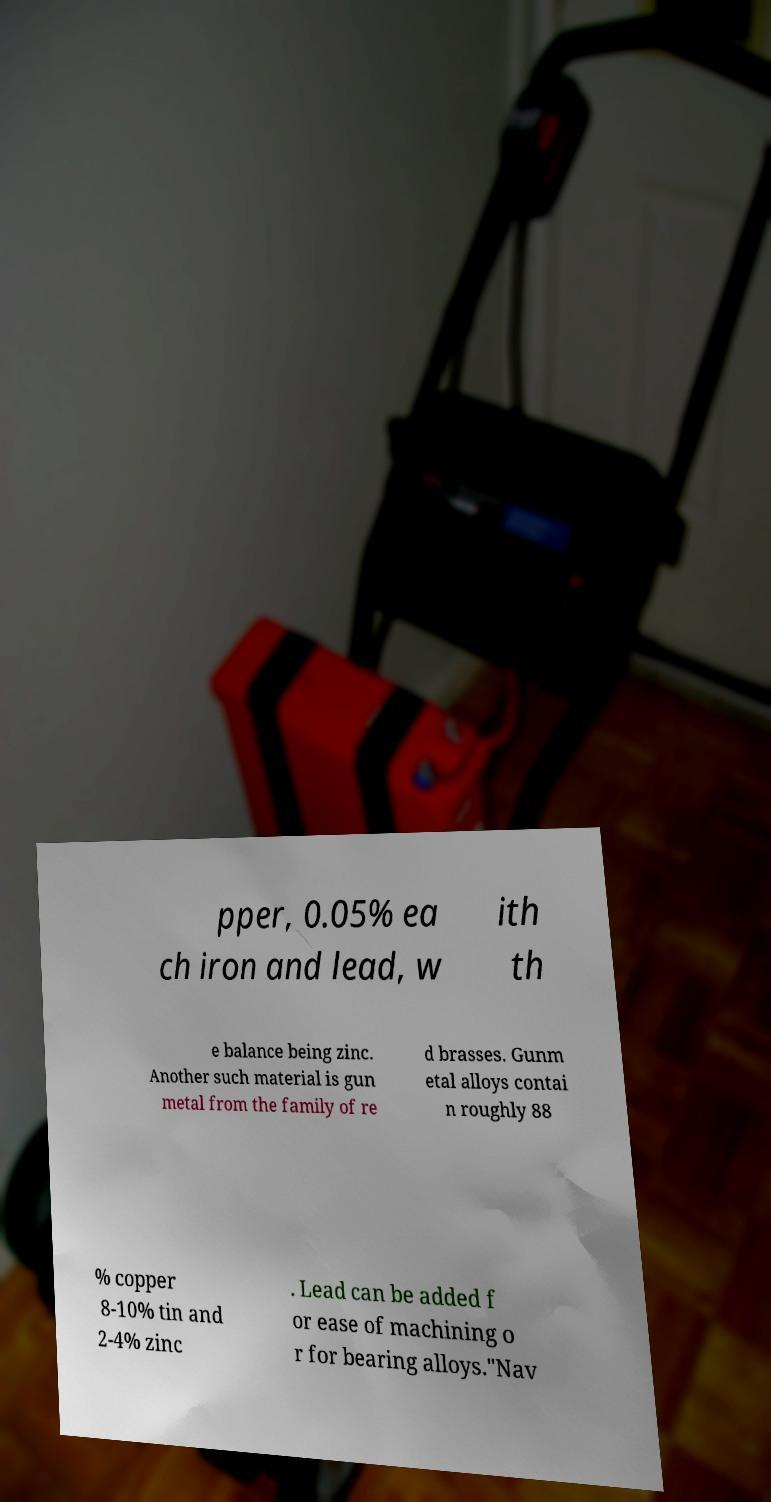Please read and relay the text visible in this image. What does it say? pper, 0.05% ea ch iron and lead, w ith th e balance being zinc. Another such material is gun metal from the family of re d brasses. Gunm etal alloys contai n roughly 88 % copper 8-10% tin and 2-4% zinc . Lead can be added f or ease of machining o r for bearing alloys."Nav 